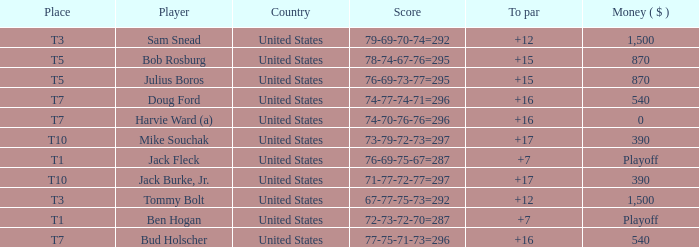What is average to par when Bud Holscher is the player? 16.0. 